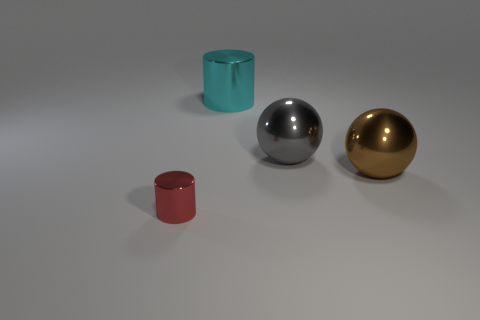Add 1 large cylinders. How many objects exist? 5 Subtract all gray spheres. How many spheres are left? 1 Subtract 2 cylinders. How many cylinders are left? 0 Subtract all green cubes. How many purple spheres are left? 0 Subtract all large metallic objects. Subtract all small metal objects. How many objects are left? 0 Add 1 big cylinders. How many big cylinders are left? 2 Add 4 brown objects. How many brown objects exist? 5 Subtract 1 cyan cylinders. How many objects are left? 3 Subtract all gray cylinders. Subtract all blue blocks. How many cylinders are left? 2 